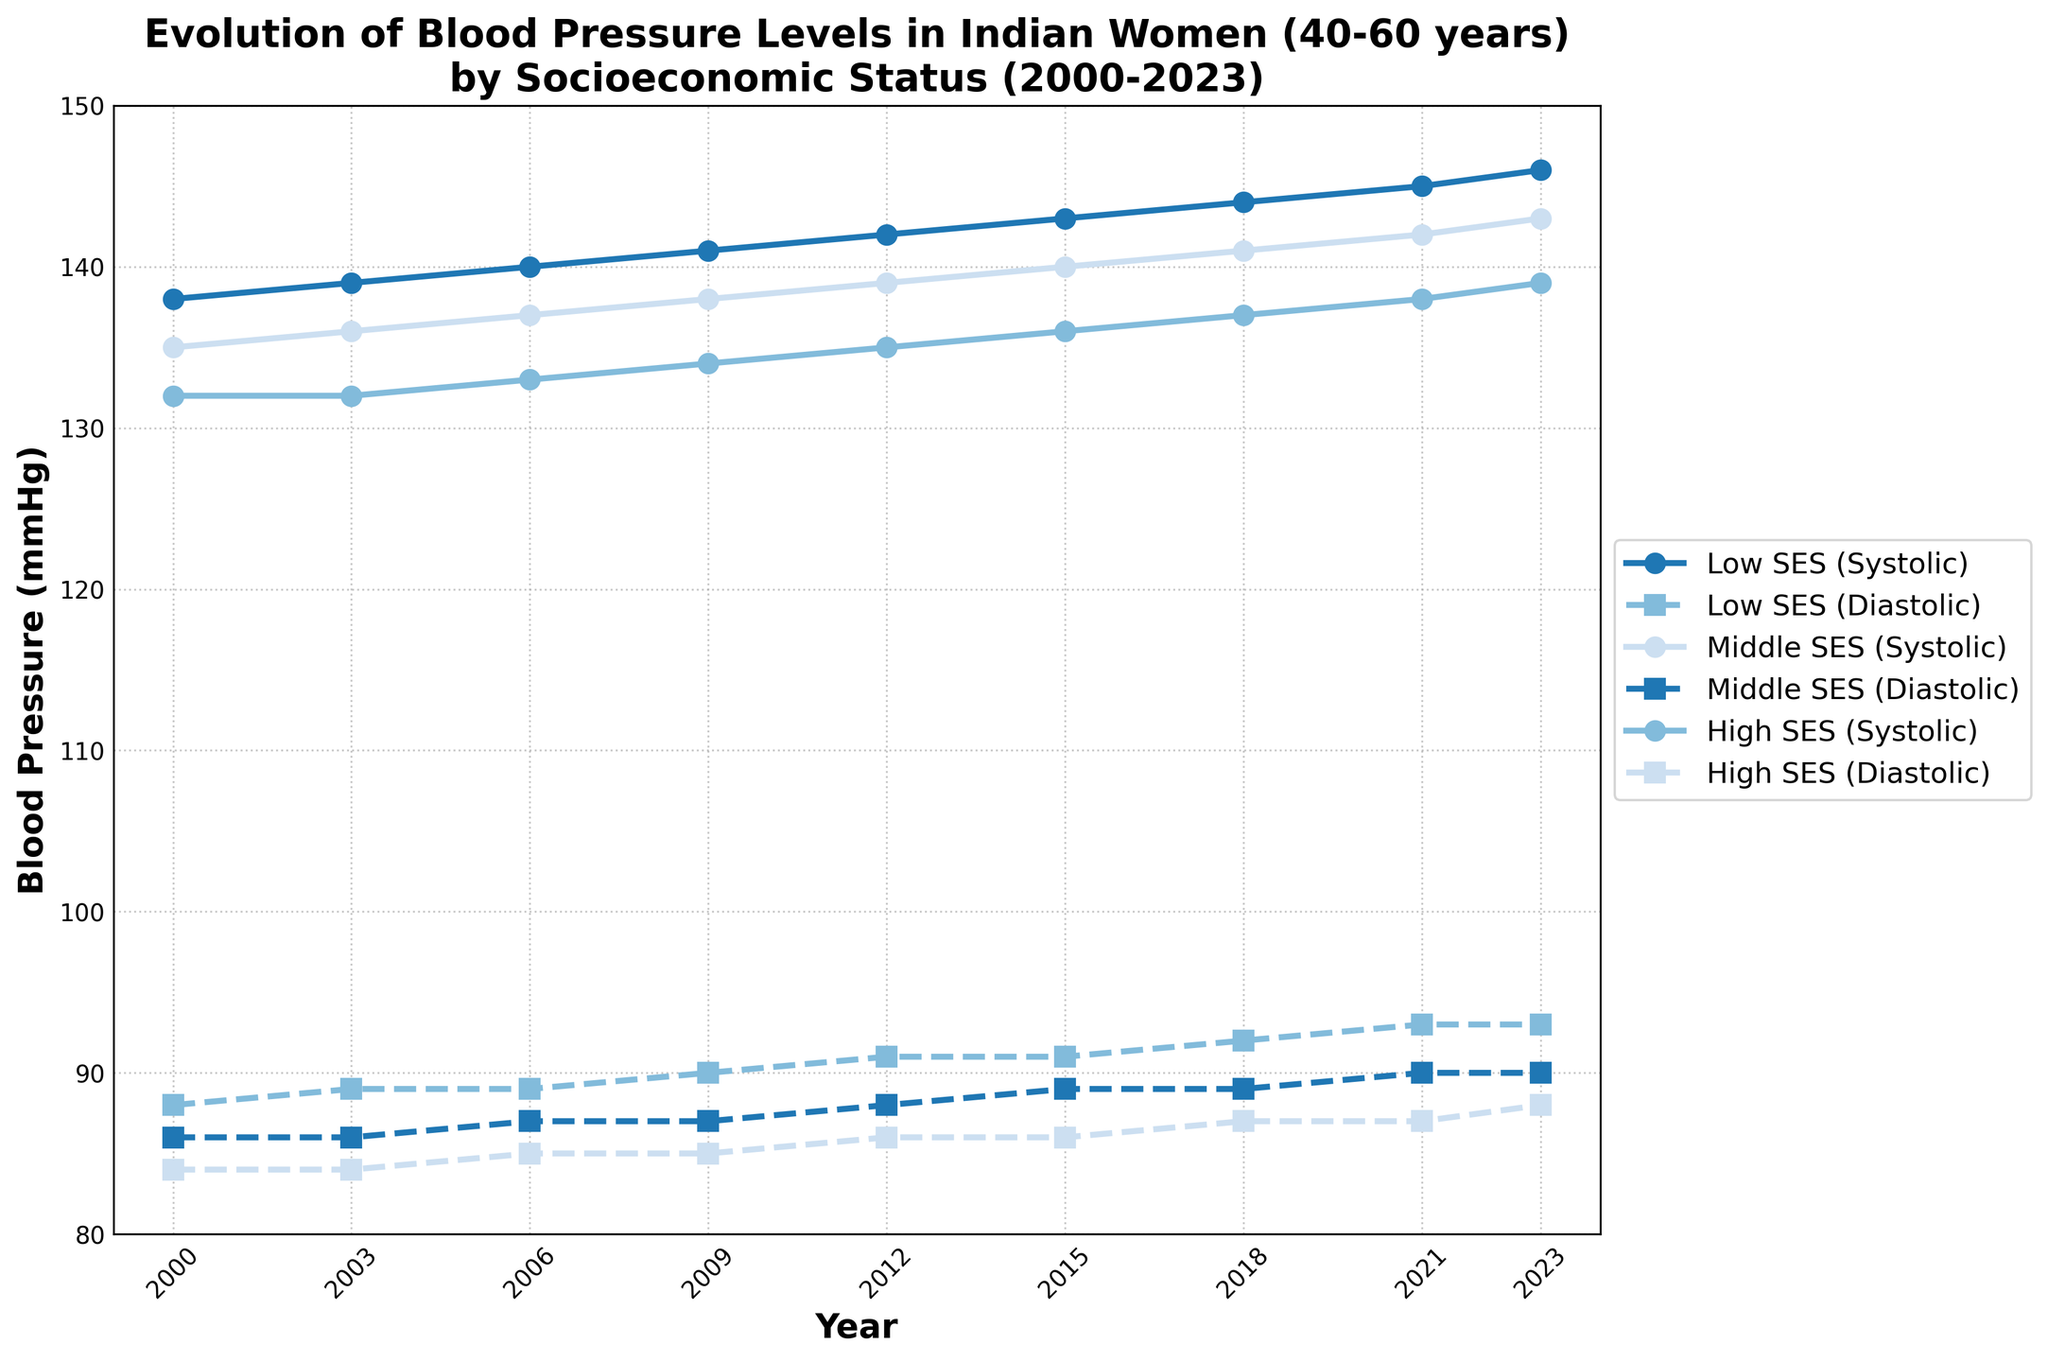What is the trend of systolic blood pressure in women of Low SES from 2000 to 2023? The trend of systolic blood pressure in women of Low SES is increasing. Starting at 138 mmHg in 2000, it gradually rises to 146 mmHg by 2023. This can be observed by the upward-sloping line for Low SES (Systolic) on the chart.
Answer: Increasing How does the diastolic blood pressure of women in Middle SES compare between 2006 and 2023? In 2006, the diastolic blood pressure for Middle SES is 87 mmHg and in 2023, it is 90 mmHg. By comparing these two values, we see an increase of 3 mmHg over this period.
Answer: Increased by 3 mmHg Which socioeconomic status group has the highest systolic blood pressure in 2023? By looking at the systolic lines in the year 2023, the Low SES group has the highest systolic blood pressure at 146 mmHg compared to the Middle SES at 143 mmHg and High SES at 139 mmHg.
Answer: Low SES Is the rate of increase in systolic blood pressure from 2000 to 2023 higher for Low SES or High SES women? The systolic blood pressure for Low SES increased from 138 mmHg (2000) to 146 mmHg (2023), an 8 mmHg increase. For High SES, it increased from 132 mmHg (2000) to 139 mmHg (2023), a 7 mmHg increase. Thus, the rate of increase is higher for Low SES women.
Answer: Low SES What is the overall change in diastolic blood pressure for High SES women from 2000 to 2023? In 2000, the diastolic blood pressure for High SES is 84 mmHg, and in 2023, it is 88 mmHg. Thus, the overall change is 88 - 84 = 4 mmHg.
Answer: Increased by 4 mmHg Are there any periods where the diastolic blood pressure for Middle SES women remains constant? The diastolic blood pressure for Middle SES women remains constant at 86 mmHg from 2000 to 2003. Between these years, the diastolic value does not change for Middle SES women.
Answer: 2000 to 2003 How does the systolic blood pressure in 2023 for Low SES women compare to the systolic blood pressure for Middle SES women in 2000? In 2023, the systolic blood pressure for Low SES women is 146 mmHg. In 2000, the systolic blood pressure for Middle SES women is 135 mmHg. By comparing these values, we see that Low SES women in 2023 have a systolic blood pressure that is 11 mmHg higher.
Answer: 11 mmHg higher Which socioeconomic group shows the smallest overall increase in systolic blood pressure from 2000 to 2023? For High SES, the systolic blood pressure increased from 132 mmHg (2000) to 139 mmHg (2023), an increase of 7 mmHg. For Middle SES, it increased from 135 mmHg to 143 mmHg, an 8 mmHg increase. For Low SES, it increased from 138 mmHg to 146 mmHg, an 8 mmHg increase. Therefore, High SES shows the smallest overall increase.
Answer: High SES 